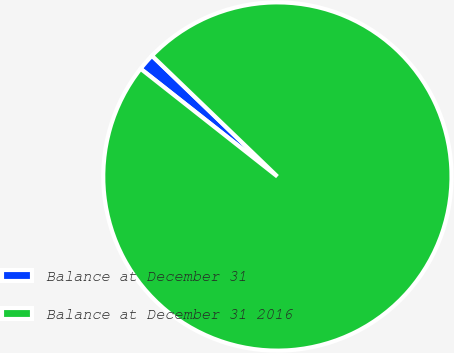<chart> <loc_0><loc_0><loc_500><loc_500><pie_chart><fcel>Balance at December 31<fcel>Balance at December 31 2016<nl><fcel>1.58%<fcel>98.42%<nl></chart> 